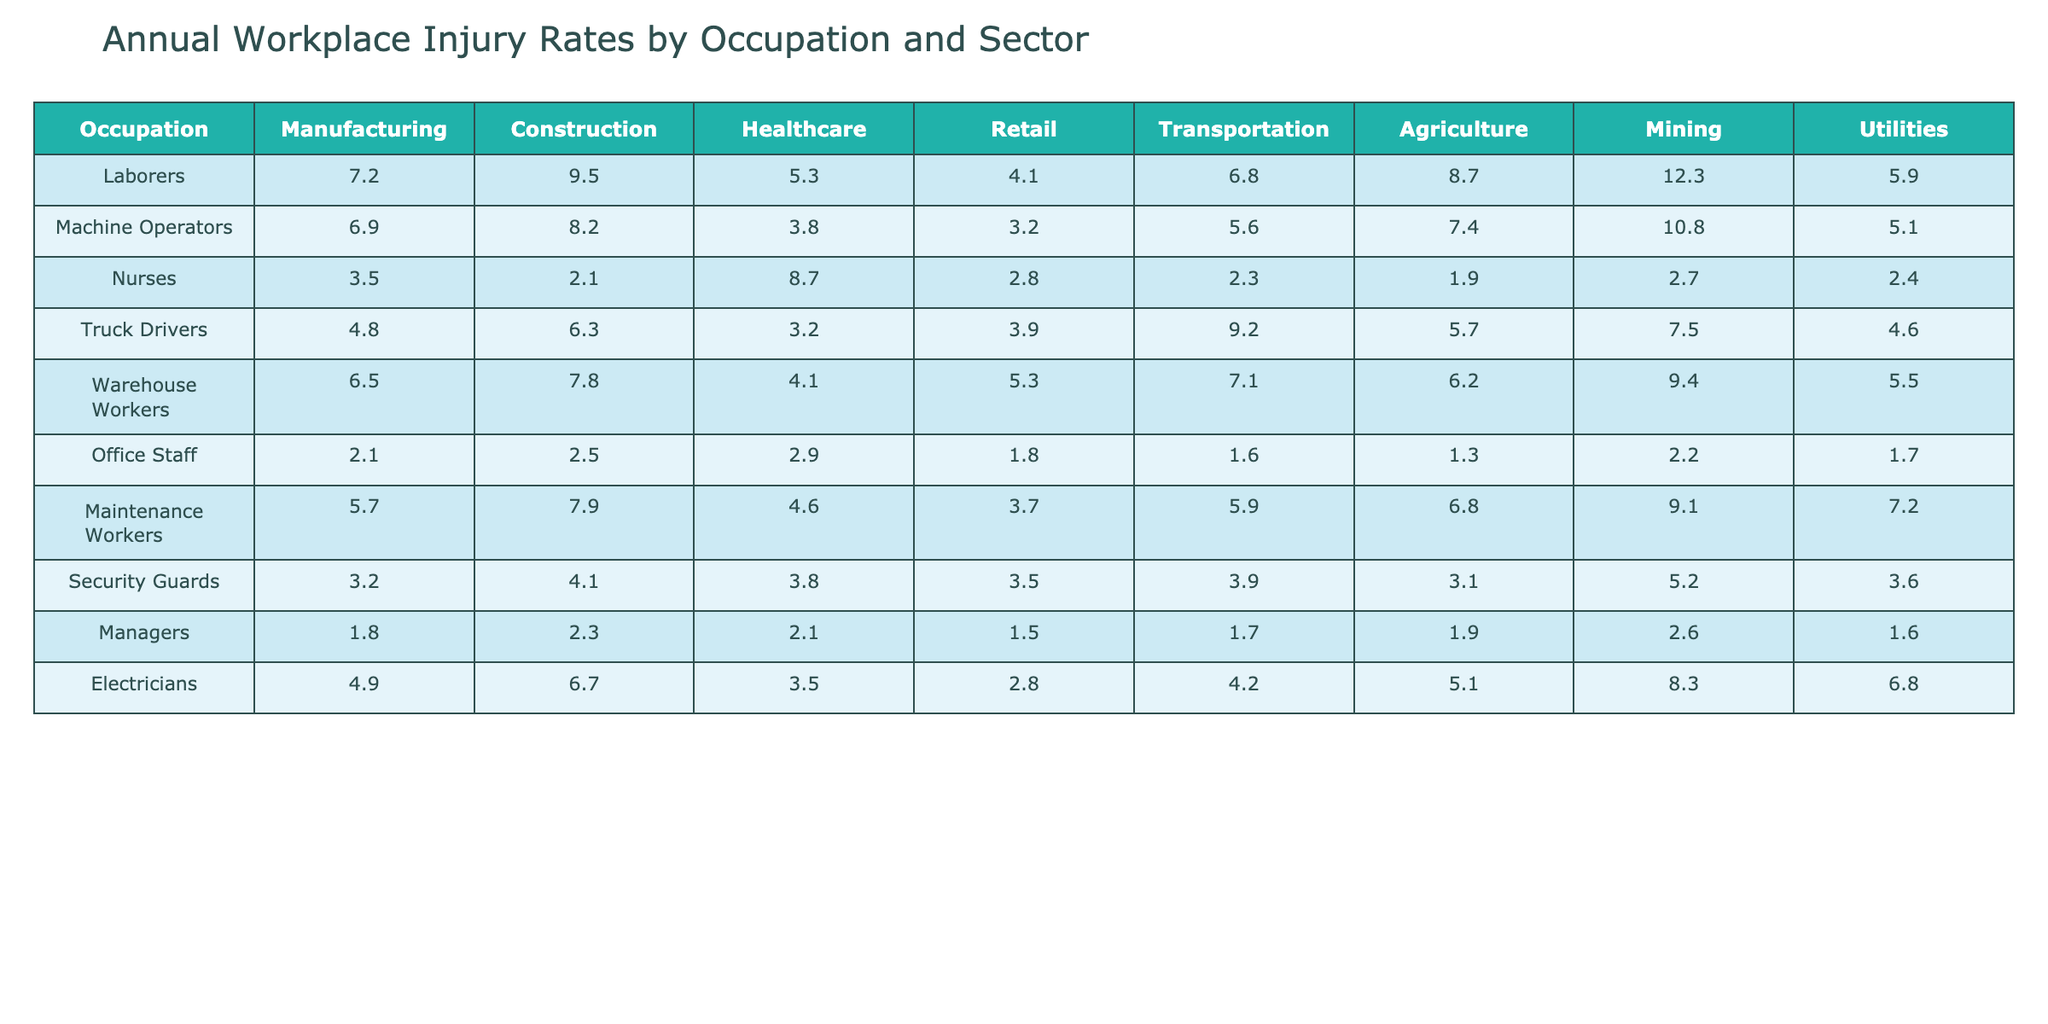What is the workplace injury rate for Laborers in the Manufacturing sector? The injury rate for Laborers in the Manufacturing sector is directly listed in the table. Looking at that specific row and column, the value is 7.2.
Answer: 7.2 Which occupation has the highest injury rate in Construction? By examining the Construction column, the highest value is 9.5, which corresponds to Laborers.
Answer: Laborers What is the average injury rate for Nurses across all sectors? To calculate the average, sum the injury rates for Nurses across all sectors (3.5 + 2.1 + 8.7 + 2.8 + 2.3 + 1.9 + 2.7 + 2.4 = 23.4), and divide by the number of sectors (8). Thus, 23.4 / 8 = 2.925.
Answer: 2.93 Which occupation has a higher injury rate in Agriculture: Truck Drivers or Machine Operators? Comparing the values for Truck Drivers (5.7) and Machine Operators (7.4) in the Agriculture column, 5.7 is less than 7.4. Therefore, Machine Operators have a higher injury rate.
Answer: Machine Operators True or False: The injury rate for Electricians is the same in Utilities and Transportation. Electricians have an injury rate of 6.8 in Utilities and 4.2 in Transportation. Since 6.8 is not equal to 4.2, the statement is false.
Answer: False What is the difference in injury rates between Laborers in Mining and Managers in Mining? The injury rate for Laborers in Mining is 12.3 and for Managers in Mining it is 2.6. To find the difference, subtract: 12.3 - 2.6 = 9.7.
Answer: 9.7 Which sector shows the lowest average injury rate across all occupations? To find the sector with the lowest average, calculate the average rates for each sector: Manufacturing (5.45), Construction (5.13), Healthcare (4.63), Retail (3.55), Transportation (5.72), Agriculture (5.38), Mining (7.38), Utilities (5.10). The lowest average rate is for Retail.
Answer: Retail What occupation has the lowest injury rate in the Healthcare sector? In the Healthcare column, comparing the injury rates of each occupation, the lowest value is 1.9, which belongs to Agriculture workers.
Answer: Agriculture Workers 